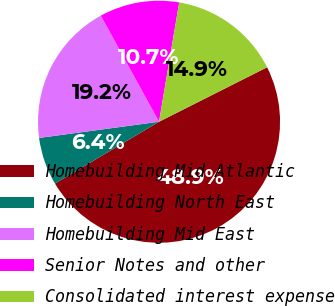Convert chart. <chart><loc_0><loc_0><loc_500><loc_500><pie_chart><fcel>Homebuilding Mid Atlantic<fcel>Homebuilding North East<fcel>Homebuilding Mid East<fcel>Senior Notes and other<fcel>Consolidated interest expense<nl><fcel>48.89%<fcel>6.4%<fcel>19.15%<fcel>10.65%<fcel>14.9%<nl></chart> 